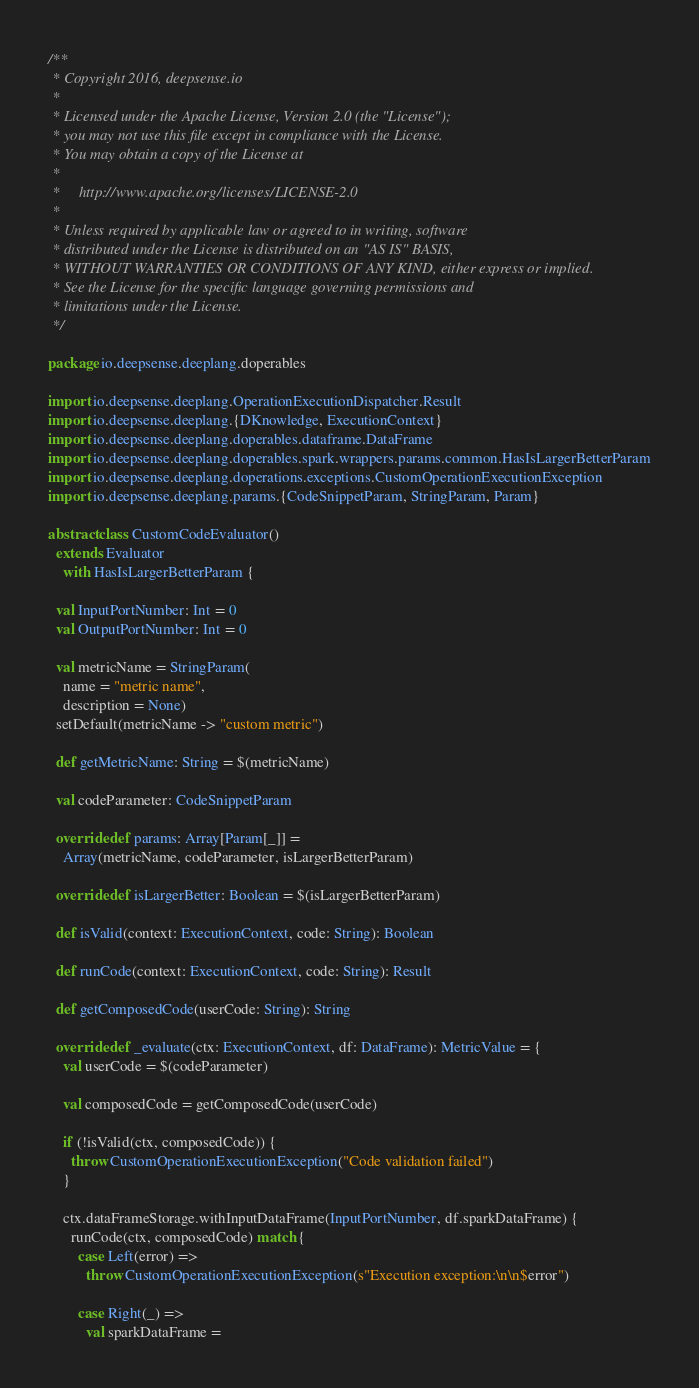<code> <loc_0><loc_0><loc_500><loc_500><_Scala_>/**
 * Copyright 2016, deepsense.io
 *
 * Licensed under the Apache License, Version 2.0 (the "License");
 * you may not use this file except in compliance with the License.
 * You may obtain a copy of the License at
 *
 *     http://www.apache.org/licenses/LICENSE-2.0
 *
 * Unless required by applicable law or agreed to in writing, software
 * distributed under the License is distributed on an "AS IS" BASIS,
 * WITHOUT WARRANTIES OR CONDITIONS OF ANY KIND, either express or implied.
 * See the License for the specific language governing permissions and
 * limitations under the License.
 */

package io.deepsense.deeplang.doperables

import io.deepsense.deeplang.OperationExecutionDispatcher.Result
import io.deepsense.deeplang.{DKnowledge, ExecutionContext}
import io.deepsense.deeplang.doperables.dataframe.DataFrame
import io.deepsense.deeplang.doperables.spark.wrappers.params.common.HasIsLargerBetterParam
import io.deepsense.deeplang.doperations.exceptions.CustomOperationExecutionException
import io.deepsense.deeplang.params.{CodeSnippetParam, StringParam, Param}

abstract class CustomCodeEvaluator()
  extends Evaluator
    with HasIsLargerBetterParam {

  val InputPortNumber: Int = 0
  val OutputPortNumber: Int = 0

  val metricName = StringParam(
    name = "metric name",
    description = None)
  setDefault(metricName -> "custom metric")

  def getMetricName: String = $(metricName)

  val codeParameter: CodeSnippetParam

  override def params: Array[Param[_]] =
    Array(metricName, codeParameter, isLargerBetterParam)

  override def isLargerBetter: Boolean = $(isLargerBetterParam)

  def isValid(context: ExecutionContext, code: String): Boolean

  def runCode(context: ExecutionContext, code: String): Result

  def getComposedCode(userCode: String): String

  override def _evaluate(ctx: ExecutionContext, df: DataFrame): MetricValue = {
    val userCode = $(codeParameter)

    val composedCode = getComposedCode(userCode)

    if (!isValid(ctx, composedCode)) {
      throw CustomOperationExecutionException("Code validation failed")
    }

    ctx.dataFrameStorage.withInputDataFrame(InputPortNumber, df.sparkDataFrame) {
      runCode(ctx, composedCode) match {
        case Left(error) =>
          throw CustomOperationExecutionException(s"Execution exception:\n\n$error")

        case Right(_) =>
          val sparkDataFrame =</code> 